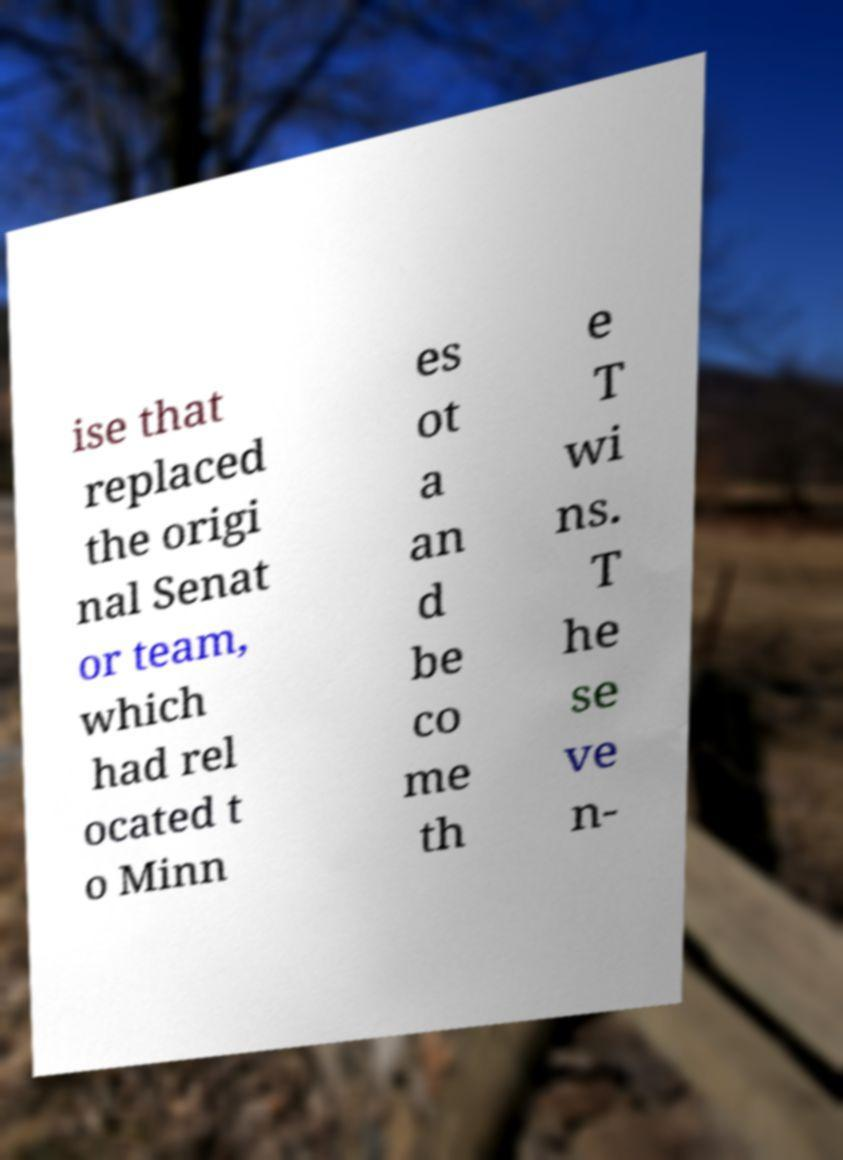Could you extract and type out the text from this image? ise that replaced the origi nal Senat or team, which had rel ocated t o Minn es ot a an d be co me th e T wi ns. T he se ve n- 